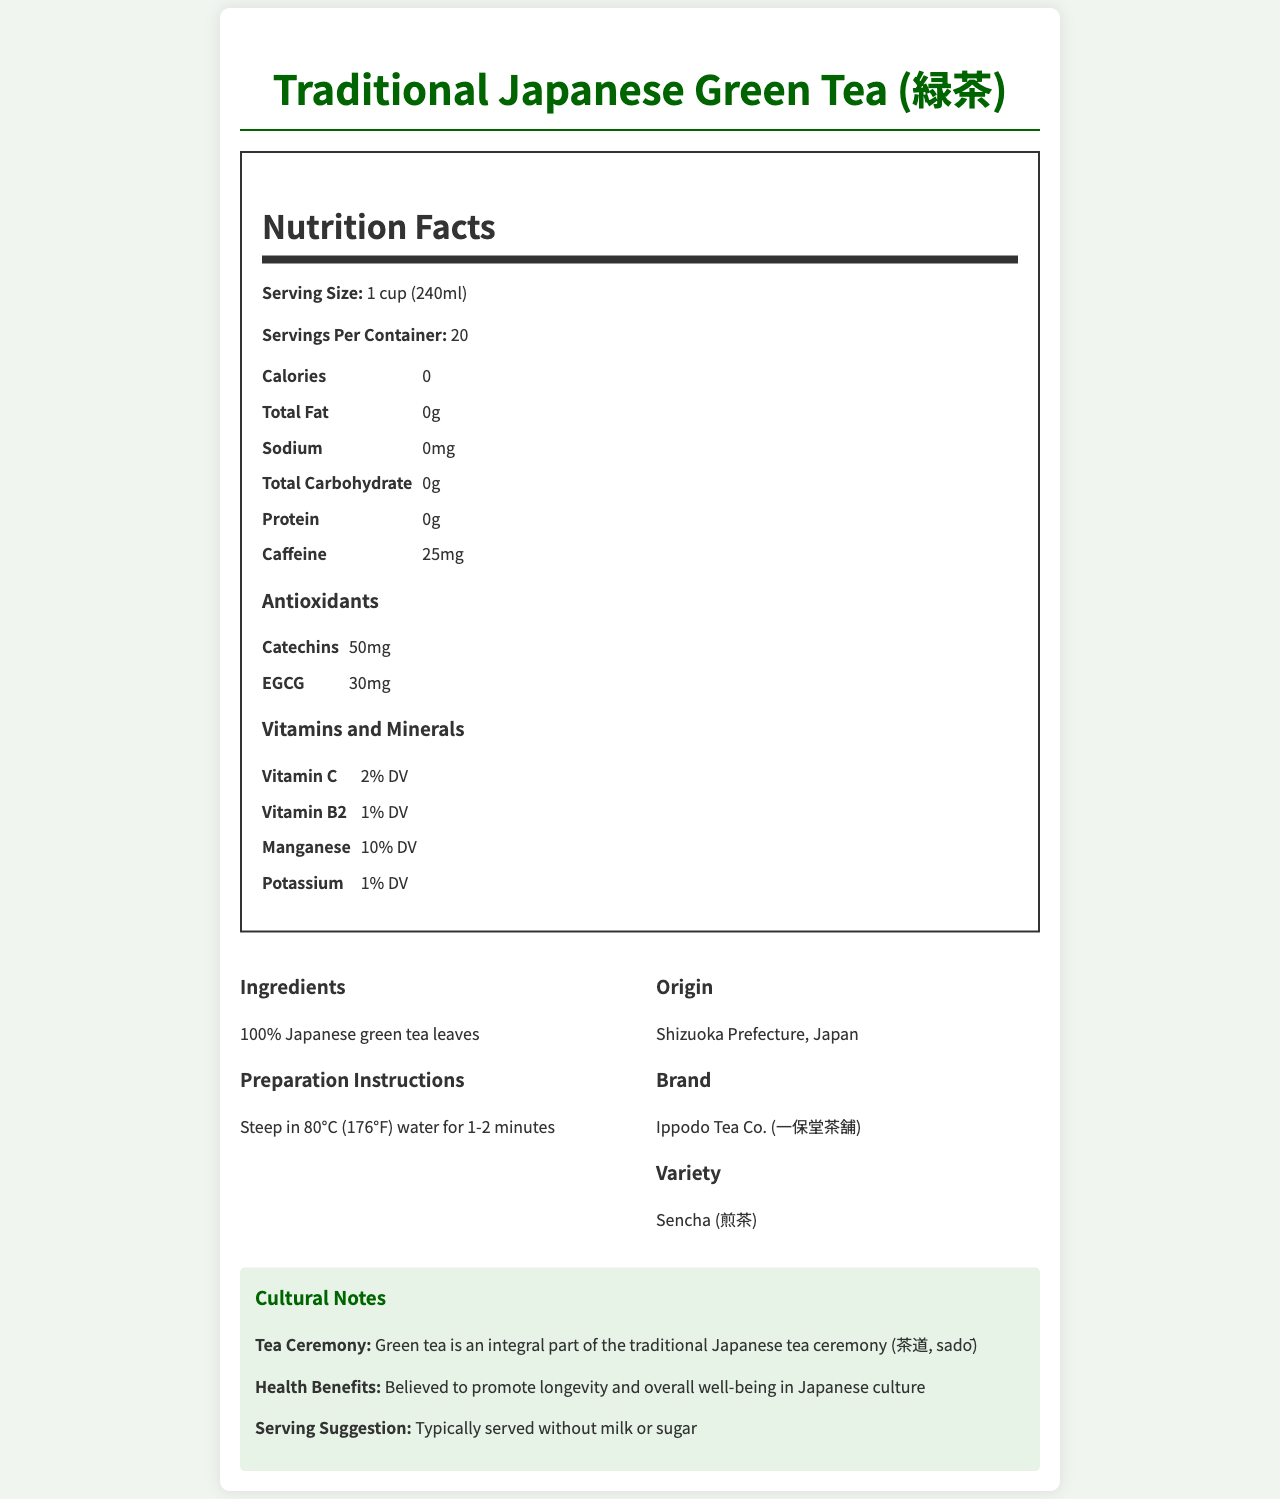what is the serving size? The serving size is stated as 1 cup (240ml) in the document.
Answer: 1 cup (240ml) how many calories are in each serving? The document specifies that each serving has 0 calories.
Answer: 0 what is the total carbohydrate content per serving? The total carbohydrate content per serving is listed as 0g.
Answer: 0g how much caffeine does each serving contain? Each serving contains 25mg of caffeine according to the document.
Answer: 25mg where does this green tea originate from? The origin of the green tea is mentioned as Shizuoka Prefecture, Japan.
Answer: Shizuoka Prefecture, Japan how much catechin is present in each serving? The document states that each serving contains 50mg of catechins.
Answer: 50mg how should the green tea be prepared? The preparation instructions are to steep the green tea in 80°C (176°F) water for 1-2 minutes.
Answer: Steep in 80°C (176°F) water for 1-2 minutes which vitamins are present in the green tea? A. Vitamin A and Vitamin C B. Vitamin B2 and Vitamin C C. Vitamin D and Vitamin E D. Vitamin K and Vitamin B12 The document lists Vitamin C and Vitamin B2 as the vitamins present in the green tea.
Answer: B how much manganese is in each serving? A. 1% DV B. 5% DV C. 10% DV D. 20% DV The manganese content is listed as 10% DV per serving.
Answer: C true or false: this green tea contains sodium. The sodium content per serving is listed as 0mg, indicating the tea contains no sodium.
Answer: False can this green tea be certified as organic? The document mentions certifications, including JAS Organic, indicating that the tea is certified as organic.
Answer: Yes describe the cultural significance of this green tea. The document highlights the cultural importance by noting its role in the tea ceremony and its health benefits, along with serving preferences.
Answer: Green tea is integral to the traditional Japanese tea ceremony (茶道, sadō) and is believed to promote longevity and well-being in Japanese culture. It is typically served without milk or sugar. what is the antioxidant EGCG content in each serving? The document specifies that each serving contains 30mg of EGCG.
Answer: 30mg what is the brand name of this green tea? The brand name is provided as Ippodo Tea Co. (一保堂茶舗).
Answer: Ippodo Tea Co. (一保堂茶舗) how much protein is in each serving of the green tea? A. 0g B. 1g C. 2g D. 5g The document lists the protein content per serving as 0g.
Answer: A are there allergen concerns related to this green tea? The document states that the tea is processed in a facility that handles soy, which could be an allergen concern.
Answer: Yes how many servings are there in one container of this green tea? The document specifies that there are 20 servings per container.
Answer: 20 what is the total fat content per serving? The document mentions that the total fat content per serving is 0g.
Answer: 0g did this green tea help in promoting Japanese culture abroad? The document does not provide any information about the green tea's role in promoting Japanese culture abroad.
Answer: Not enough information 